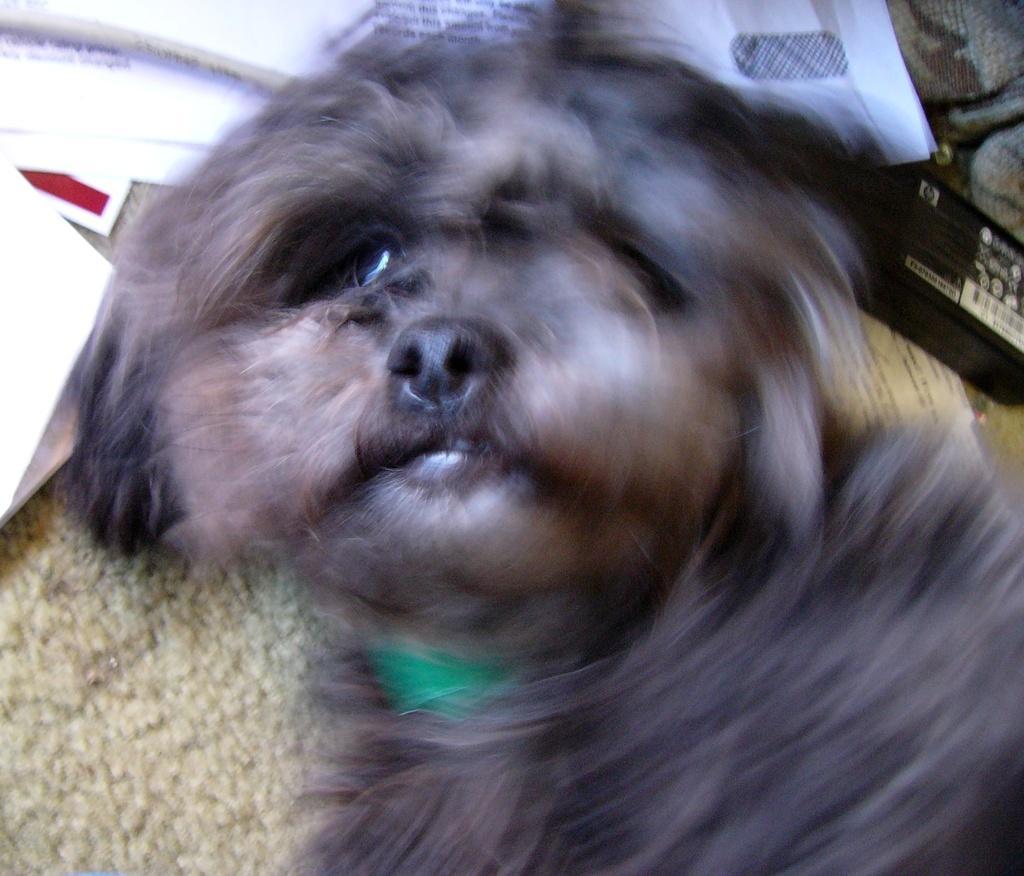Could you give a brief overview of what you see in this image? In this picture I can see there is a dog and it has black fur and there are few papers on the floor. 